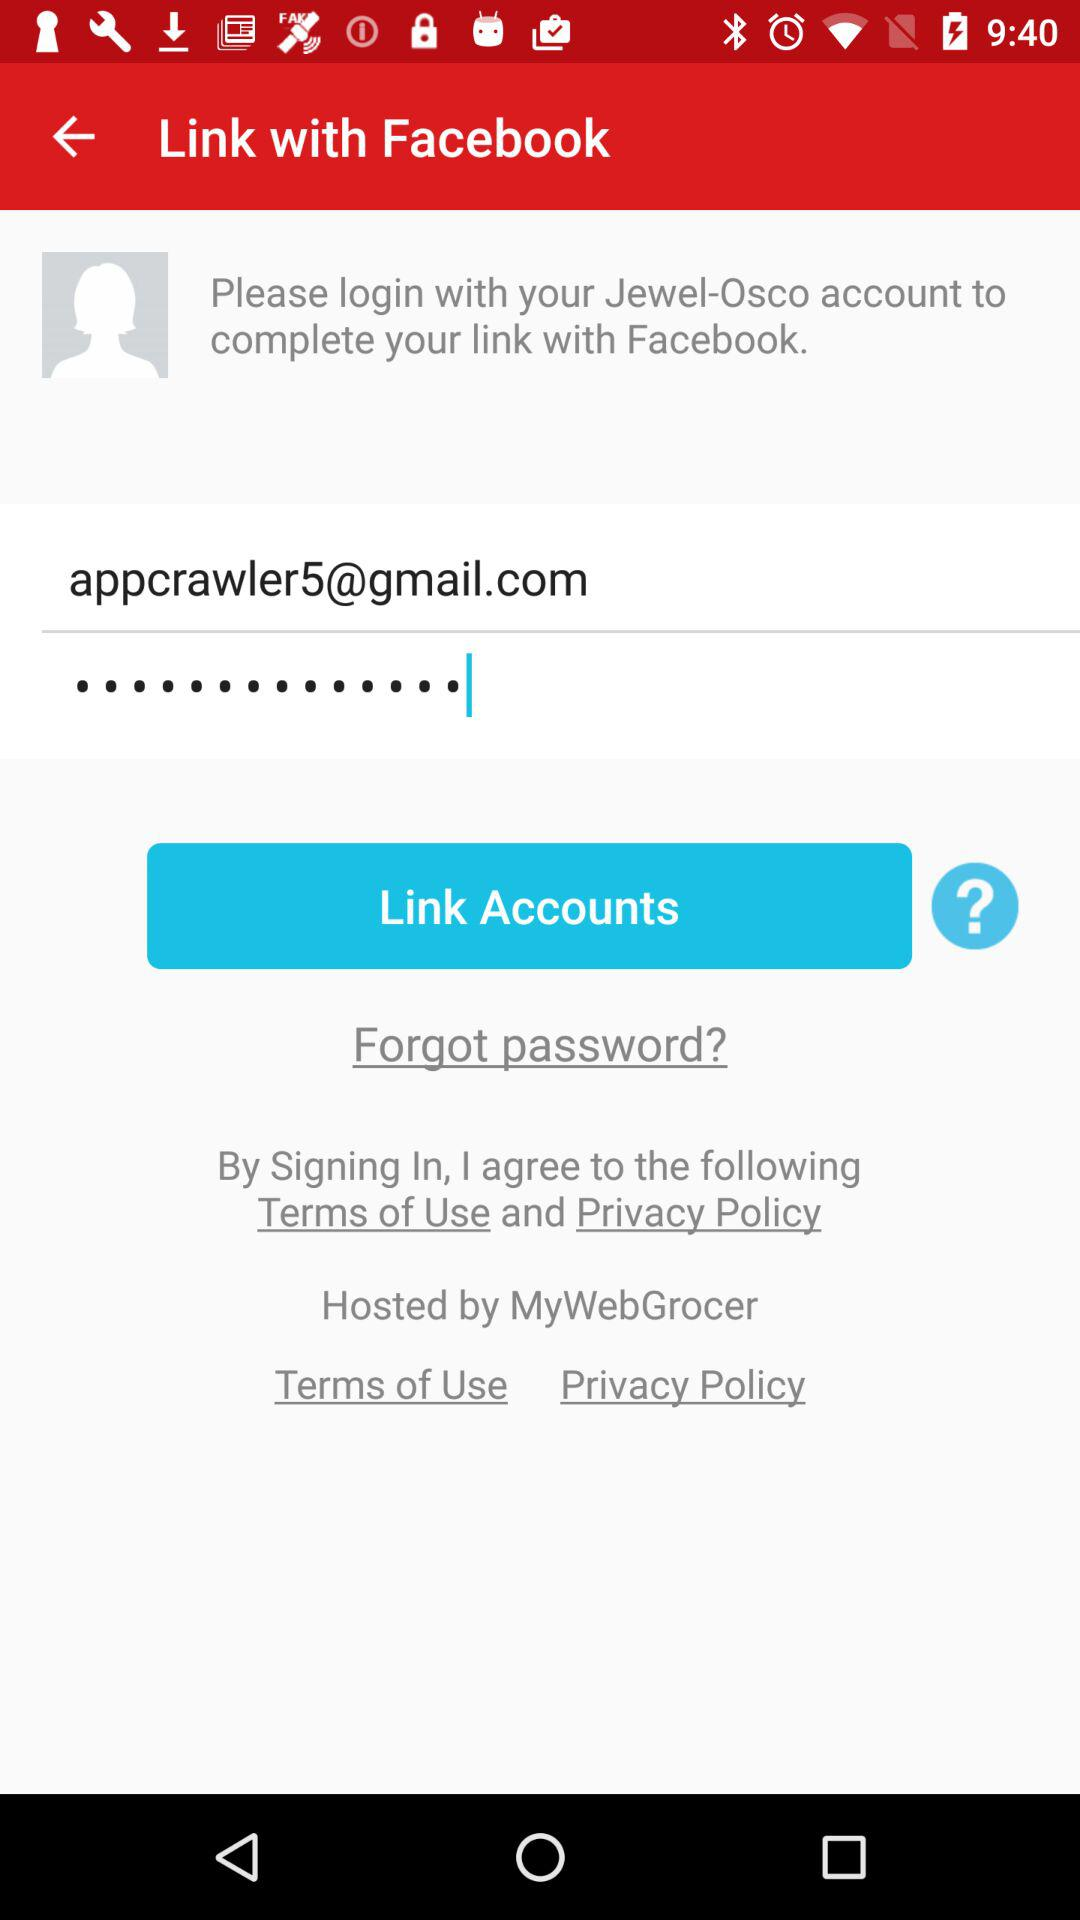What's the Gmail address? The Gmail address is appcrawler5@gmail.com. 